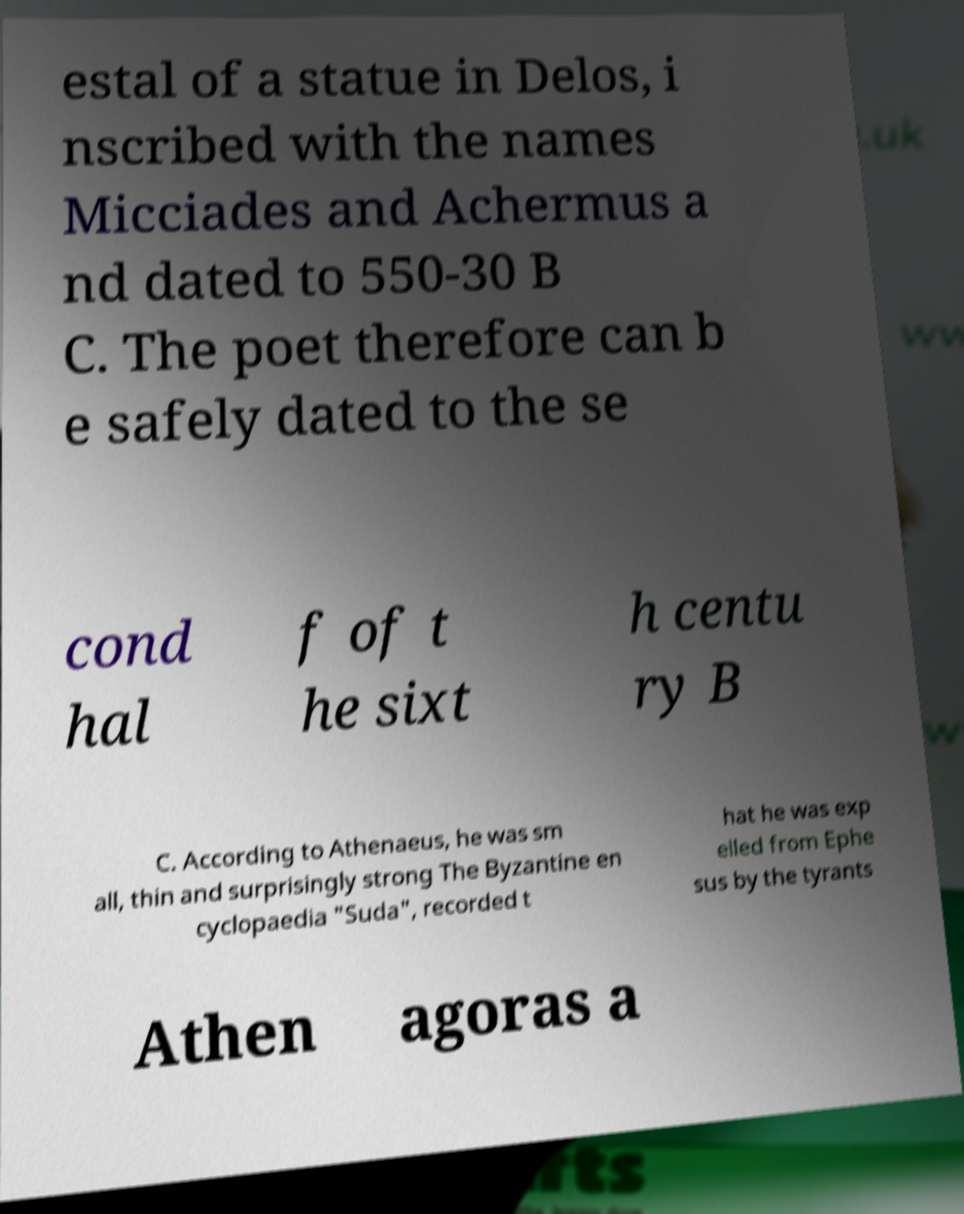For documentation purposes, I need the text within this image transcribed. Could you provide that? estal of a statue in Delos, i nscribed with the names Micciades and Achermus a nd dated to 550-30 B C. The poet therefore can b e safely dated to the se cond hal f of t he sixt h centu ry B C. According to Athenaeus, he was sm all, thin and surprisingly strong The Byzantine en cyclopaedia "Suda", recorded t hat he was exp elled from Ephe sus by the tyrants Athen agoras a 